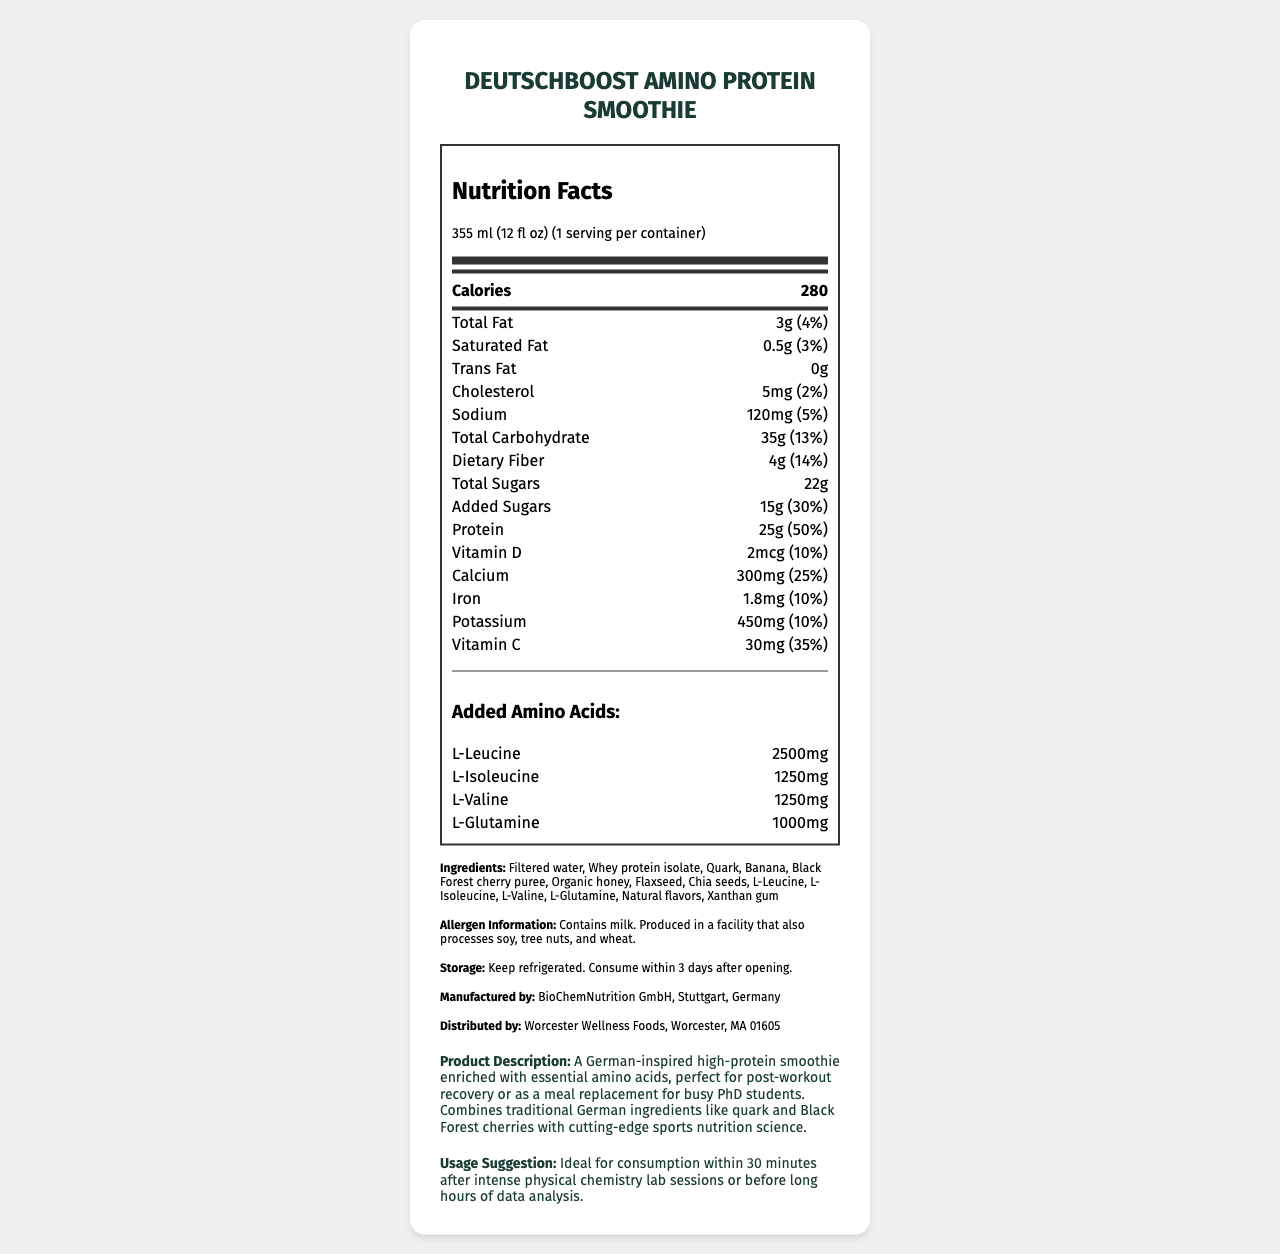what is the serving size of DeutschBoost Amino Protein Smoothie? The serving size is mentioned at the top of the nutrition facts label as "355 ml (12 fl oz)".
Answer: 355 ml (12 fl oz) how many calories are in one serving of the smoothie? The nutrition facts label specifies that each serving contains 280 calories.
Answer: 280 how much protein does one serving of the smoothie contain? According to the nutrition facts label, one serving contains 25 grams of protein.
Answer: 25g what is the percentage daily value of dietary fiber per serving? The nutrition facts indicate that the dietary fiber content per serving is 4g, which is 14% of the daily value.
Answer: 14% how many milligrams of potassium are in one serving? The nutrition label states that each serving contains 450mg of potassium.
Answer: 450mg which amino acid has the highest added amount in the smoothie? A. L-Glutamine B. L-Isoleucine C. L-Leucine D. L-Valine L-Leucine has the highest added amount at 2500mg, as listed under the "Added Amino Acids" section.
Answer: C what is the daily value percentage of added sugars? A. 25% B. 20% C. 30% D. 15% The label mentions that the added sugars amount is 15g, which is 30% of the daily value.
Answer: C does this product contain any allergens? The allergen information states that the product contains milk.
Answer: Yes describe the type of ingredients used in this smoothie. The ingredients list includes filter water, whey protein isolate, quark, banana, Black Forest cherry puree, organic honey, flaxseed, chia seeds, various amino acids, natural flavors, and xanthan gum.
Answer: The ingredients are a mix of traditional German ingredients like quark and Black Forest cherry puree, with added amino acids and natural flavors. what are the storage instructions for the product? The storage instructions advise to keep the product refrigerated and consume it within 3 days after opening.
Answer: Keep refrigerated. Consume within 3 days after opening. how much calcium is in one serving of the smoothie? The nutrition facts label states that one serving contains 300mg of calcium.
Answer: 300mg is the document able to tell us the manufacturing date of the product? The label doesn't provide information regarding the manufacturing date of the product.
Answer: No summarize the main idea of this nutrition facts label. This summary covers the key aspects of the label such as the product’s purpose, nutritional content, ingredient list, allergen information, and storage instructions.
Answer: The DeutschBoost Amino Protein Smoothie is a high-protein beverage containing traditional German ingredients and added amino acids, designed for post-workout recovery or as a meal replacement. It provides detailed nutritional information per serving size of 355 ml, including calories, fats, carbohydrates, sugars, proteins, vitamins, and amino acids. It also includes storage instructions, allergen information, and manufacturer details. 